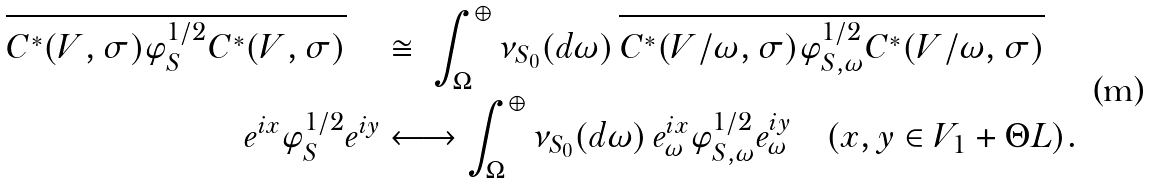<formula> <loc_0><loc_0><loc_500><loc_500>\overline { C ^ { * } ( V , \sigma ) \varphi _ { S } ^ { 1 / 2 } C ^ { * } ( V , \sigma ) } \quad & \cong \ \int _ { \Omega } ^ { \oplus } \nu _ { S _ { 0 } } ( d \omega ) \, \overline { C ^ { * } ( V / \omega , \sigma ) \varphi _ { S , \omega } ^ { 1 / 2 } C ^ { * } ( V / \omega , \sigma ) } \\ e ^ { i x } \varphi _ { S } ^ { 1 / 2 } e ^ { i y } & \longleftrightarrow \int _ { \Omega } ^ { \oplus } \nu _ { S _ { 0 } } ( d \omega ) \, e _ { \omega } ^ { i x } \varphi _ { S , \omega } ^ { 1 / 2 } e _ { \omega } ^ { i y } \quad ( x , y \in V _ { 1 } + \Theta L ) .</formula> 